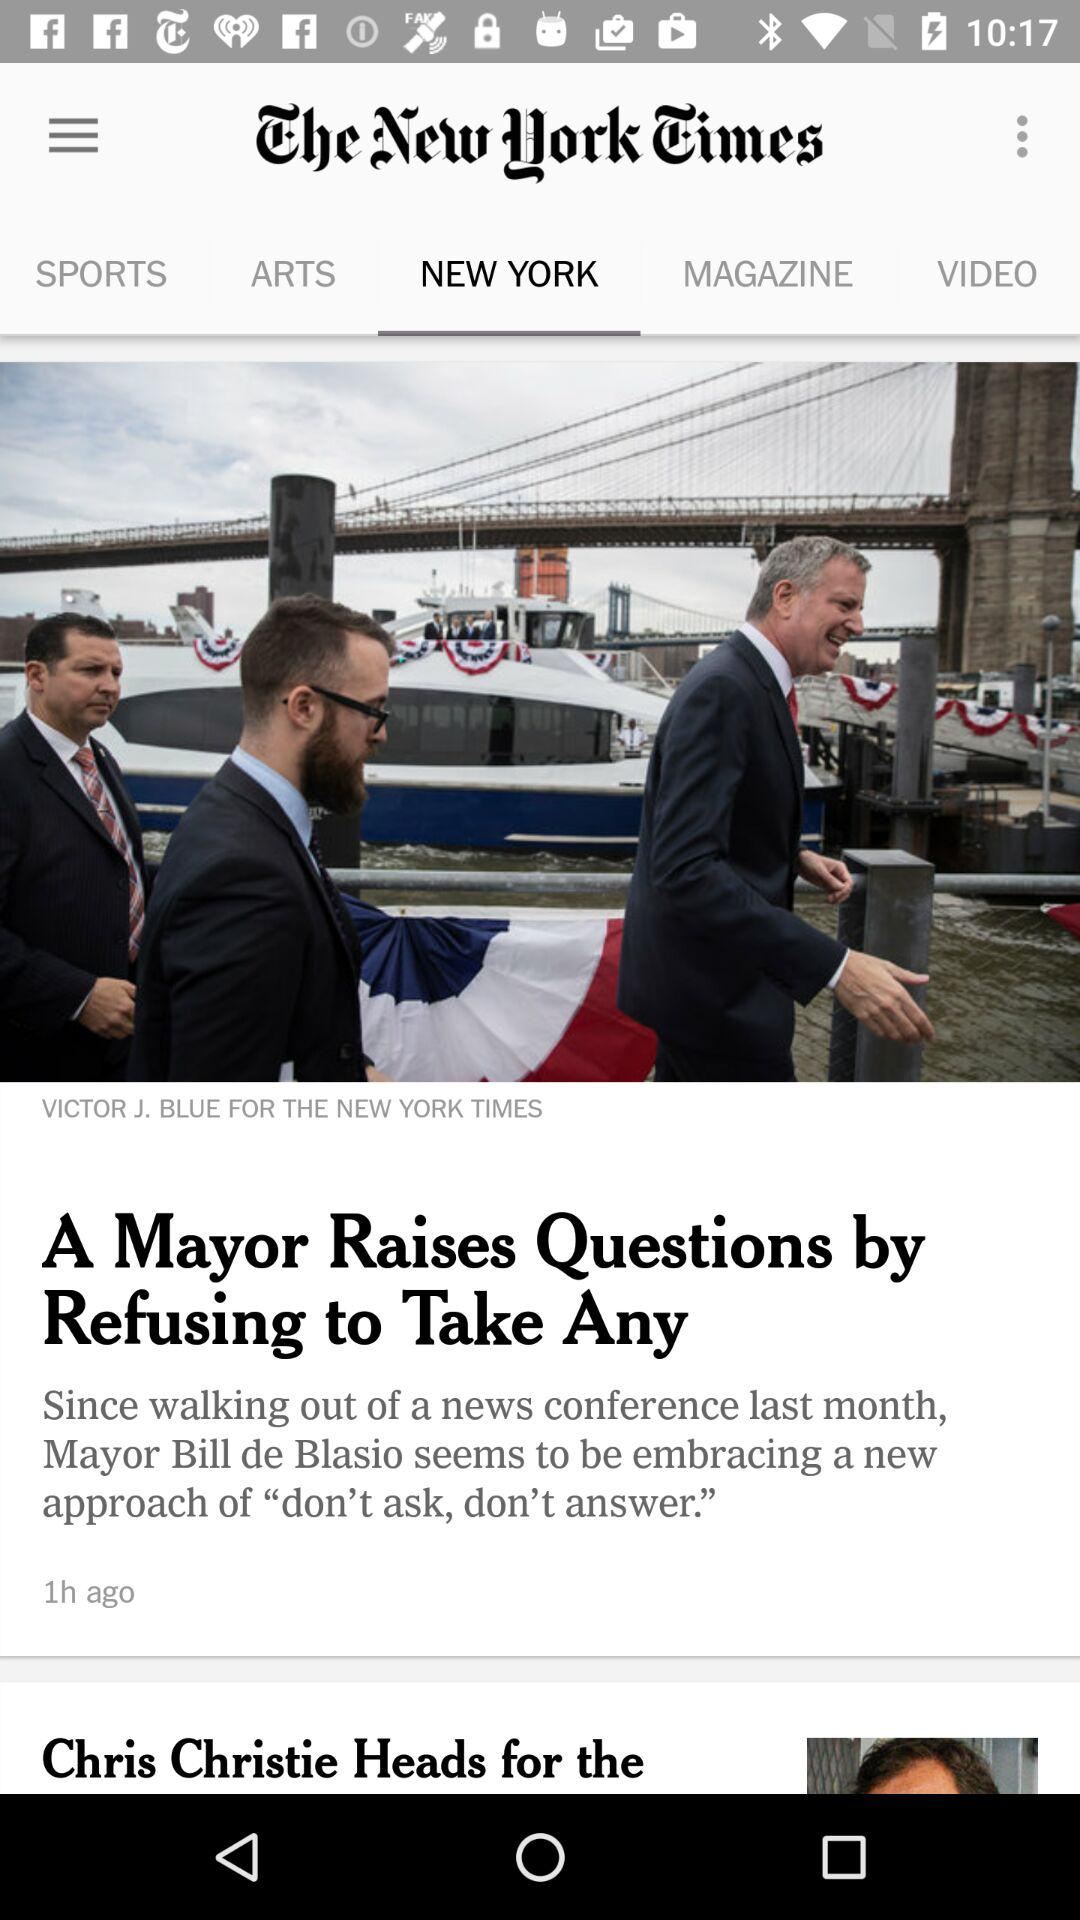Which tab am I using? You are using the "NEW YORK" tab. 